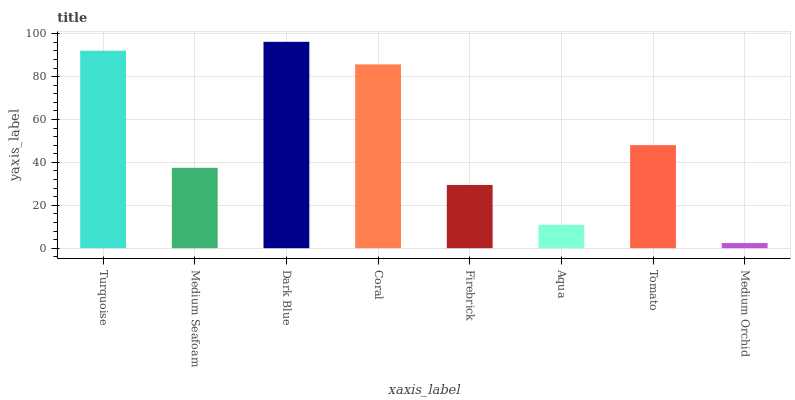Is Medium Seafoam the minimum?
Answer yes or no. No. Is Medium Seafoam the maximum?
Answer yes or no. No. Is Turquoise greater than Medium Seafoam?
Answer yes or no. Yes. Is Medium Seafoam less than Turquoise?
Answer yes or no. Yes. Is Medium Seafoam greater than Turquoise?
Answer yes or no. No. Is Turquoise less than Medium Seafoam?
Answer yes or no. No. Is Tomato the high median?
Answer yes or no. Yes. Is Medium Seafoam the low median?
Answer yes or no. Yes. Is Medium Seafoam the high median?
Answer yes or no. No. Is Turquoise the low median?
Answer yes or no. No. 